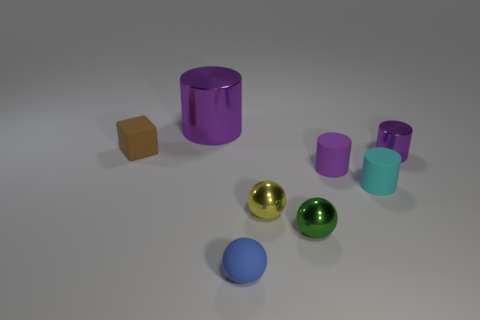What shape is the other rubber object that is the same color as the big thing?
Your response must be concise. Cylinder. What number of tiny objects are both to the left of the big cylinder and right of the big thing?
Make the answer very short. 0. How many brown blocks are on the right side of the purple cylinder behind the purple metallic object that is in front of the brown matte thing?
Give a very brief answer. 0. There is a rubber cylinder that is the same color as the large metal thing; what size is it?
Offer a very short reply. Small. There is a brown thing; what shape is it?
Keep it short and to the point. Cube. How many tiny brown blocks have the same material as the green ball?
Your answer should be very brief. 0. There is a big cylinder that is the same material as the tiny green object; what is its color?
Offer a very short reply. Purple. There is a purple matte cylinder; is its size the same as the purple metallic thing that is in front of the brown thing?
Make the answer very short. Yes. What is the purple object left of the small yellow metallic thing that is on the left side of the tiny cylinder that is on the right side of the cyan object made of?
Make the answer very short. Metal. How many things are big yellow rubber things or brown rubber objects?
Ensure brevity in your answer.  1. 